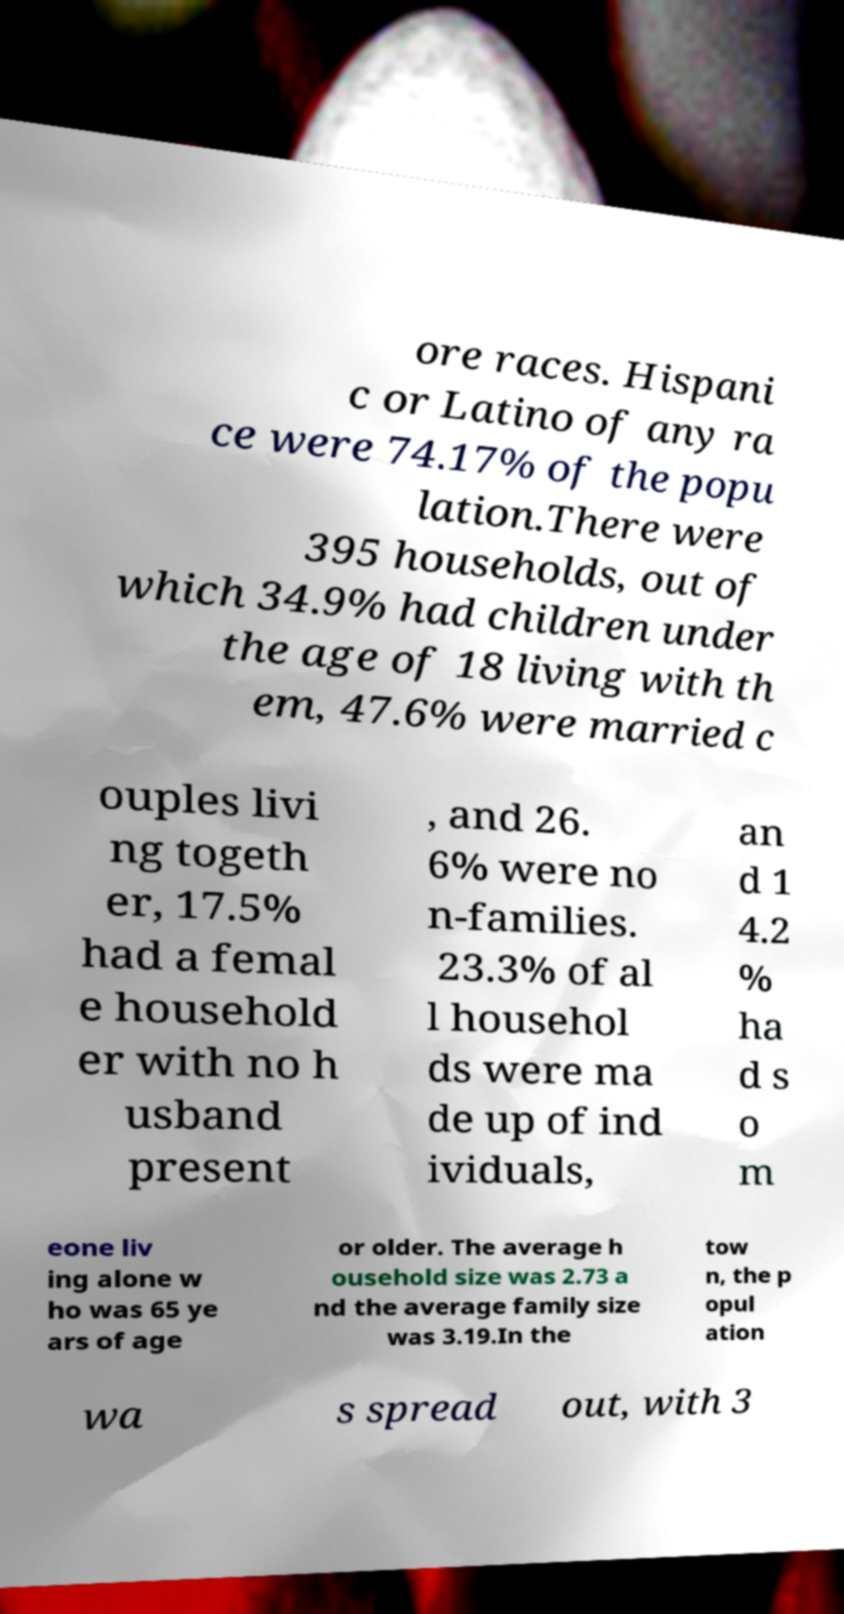What messages or text are displayed in this image? I need them in a readable, typed format. ore races. Hispani c or Latino of any ra ce were 74.17% of the popu lation.There were 395 households, out of which 34.9% had children under the age of 18 living with th em, 47.6% were married c ouples livi ng togeth er, 17.5% had a femal e household er with no h usband present , and 26. 6% were no n-families. 23.3% of al l househol ds were ma de up of ind ividuals, an d 1 4.2 % ha d s o m eone liv ing alone w ho was 65 ye ars of age or older. The average h ousehold size was 2.73 a nd the average family size was 3.19.In the tow n, the p opul ation wa s spread out, with 3 